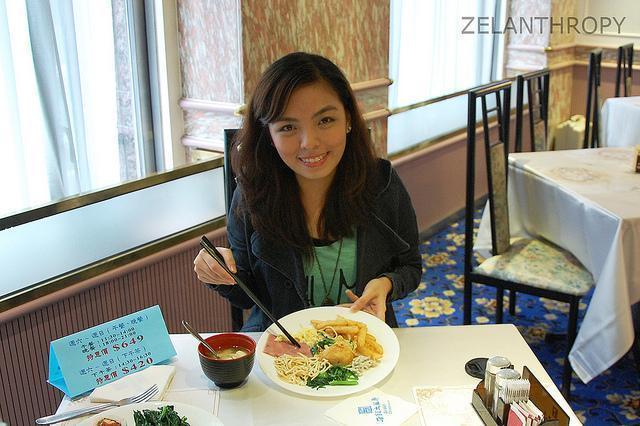Which city is most likely serving this restaurant?
Select the accurate answer and provide explanation: 'Answer: answer
Rationale: rationale.'
Options: Shanghai, singapore, hong kong, beijing. Answer: hong kong.
Rationale: The noodles and soup and writing are typical of southern china which is near this reagion. 